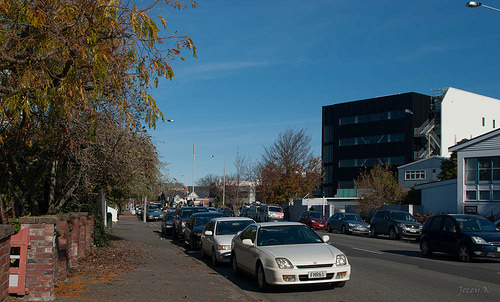<image>
Can you confirm if the car is next to the car light? No. The car is not positioned next to the car light. They are located in different areas of the scene. Is there a car in front of the car? No. The car is not in front of the car. The spatial positioning shows a different relationship between these objects. 